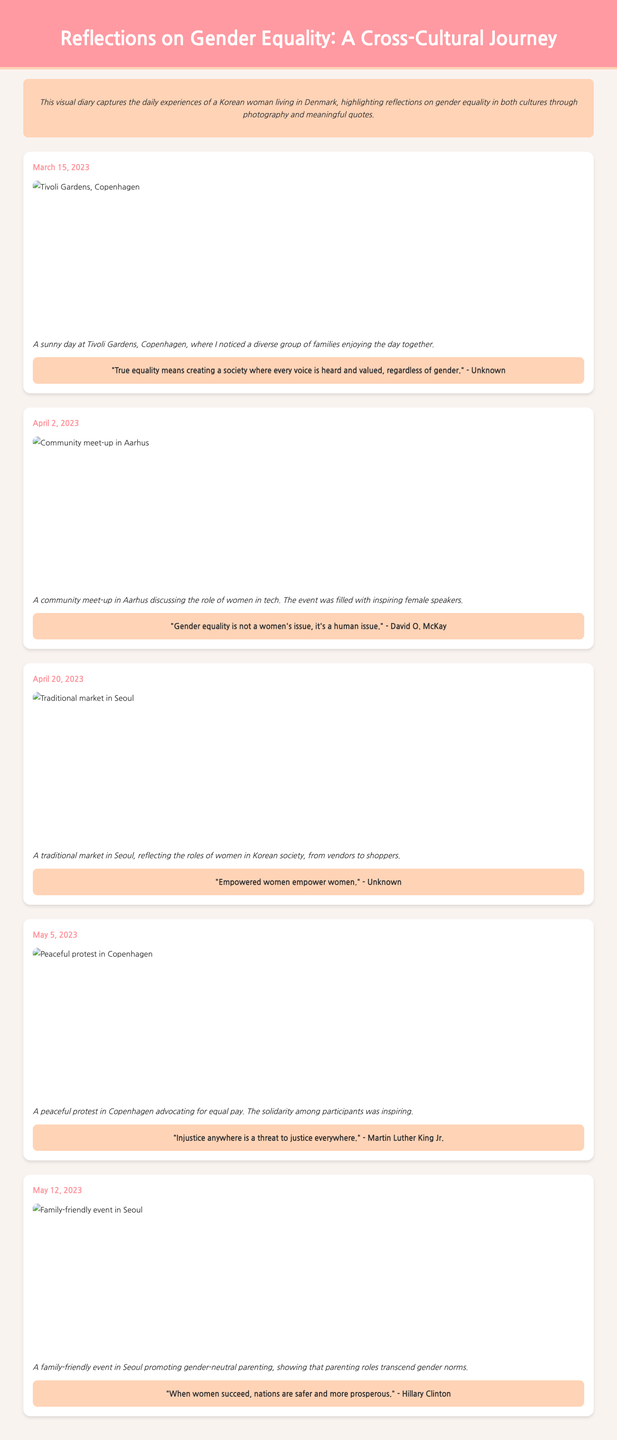what is the title of the document? The title is found in the header section of the document, which prominently displays the title of the work.
Answer: Reflections on Gender Equality: A Cross-Cultural Journey how many entries are there in the diary? The number of entries is determined by counting each distinct entry section within the document.
Answer: 5 what date is associated with the protest in Copenhagen? The date of the protest is indicated in the entry's header, which shows the date for that specific experience.
Answer: May 5, 2023 what is the caption for the second entry? The caption can be found directly below the image in the second entry, providing context to the photograph.
Answer: A community meet-up in Aarhus discussing the role of women in tech. The event was filled with inspiring female speakers who is quoted in the entry about the traditional market in Seoul? The quote is included in the entry's content, and it typically attributes the quote to a specific individual or is labeled as unknown.
Answer: Unknown what venue is mentioned in the first entry? The venue is specified in the description of the first entry as it provides the setting for the experience detailed in that entry.
Answer: Tivoli Gardens how does the diary reflect on gender equality? The diary uses personal experiences and photographs to discuss gender equality across cultures, suggesting a multifaceted perspective on the issue.
Answer: Photographs and meaningful quotes what is the main theme of the visual diary? The overarching theme is conveyed in the introduction of the document, which clearly states the focus of the visual diary.
Answer: Gender equality 